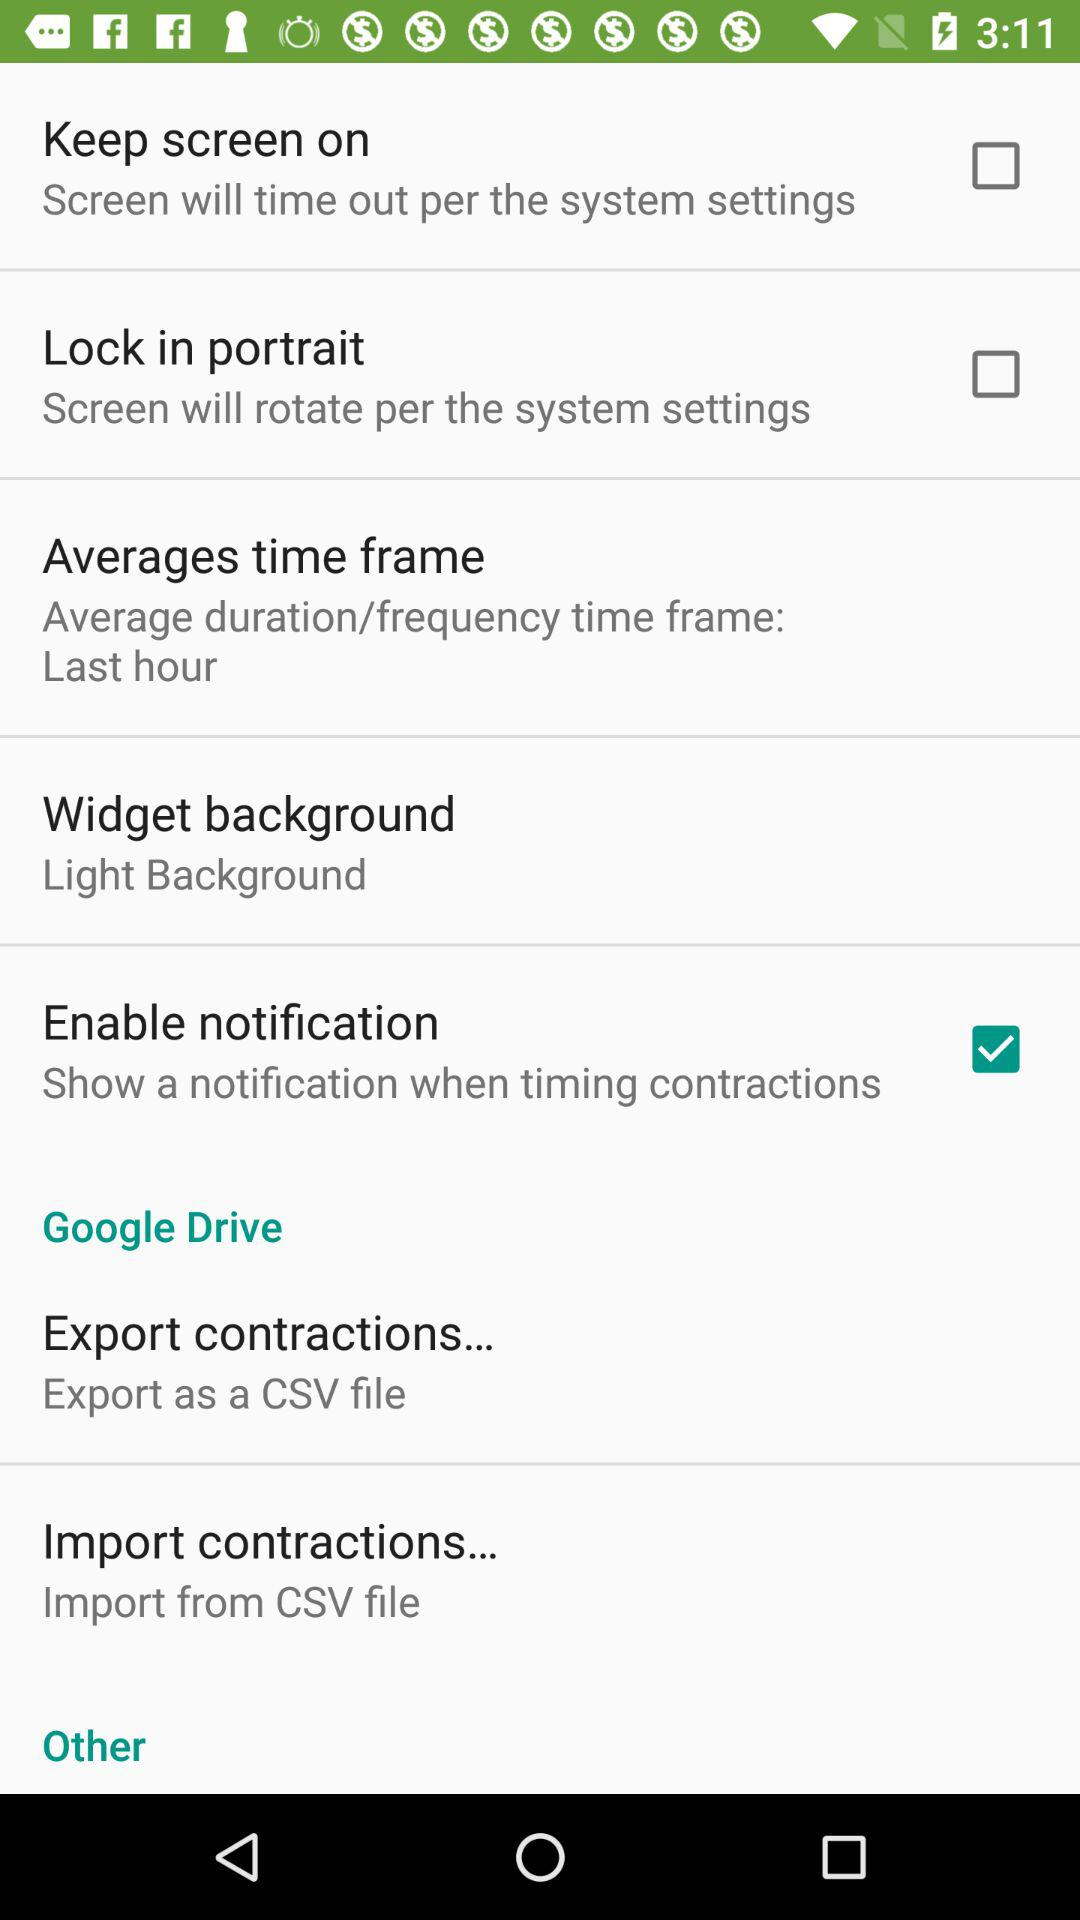What is the setting for "Widget background"? The setting is "Light Background". 